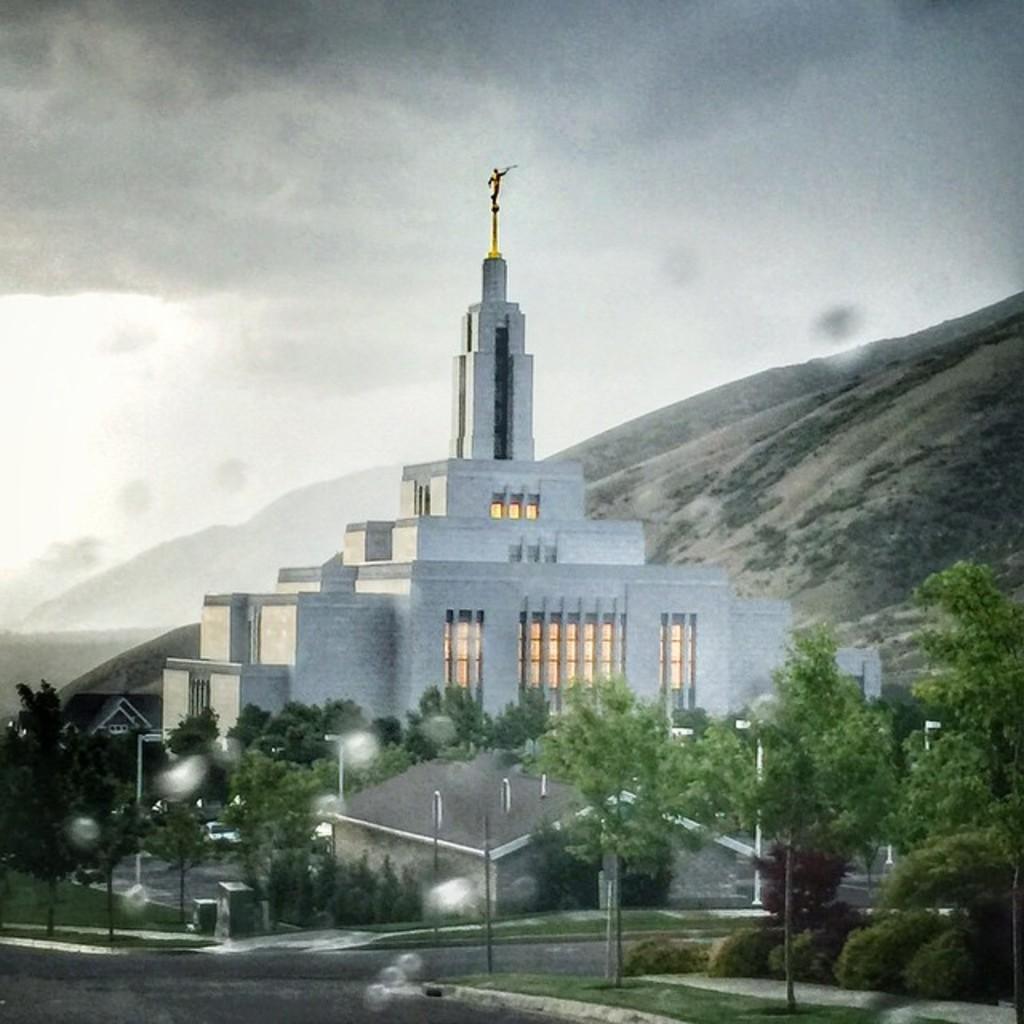In one or two sentences, can you explain what this image depicts? At the center of the image we can see there is a building, in front of the building there are some trees and street lights. In the background there is a mountain and sky. 